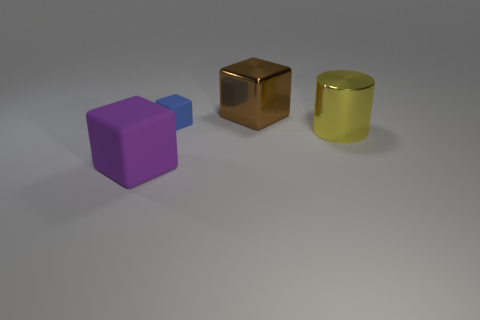How many yellow metallic cylinders have the same size as the yellow shiny thing?
Offer a terse response. 0. What number of things are rubber things that are in front of the large yellow object or tiny brown matte cubes?
Your answer should be compact. 1. Is the number of gray rubber cylinders less than the number of things?
Offer a very short reply. Yes. What shape is the big yellow thing that is made of the same material as the brown thing?
Provide a succinct answer. Cylinder. There is a big metal cylinder; are there any big cubes in front of it?
Offer a very short reply. Yes. Is the number of purple rubber objects that are to the right of the large metal cylinder less than the number of small green rubber things?
Provide a succinct answer. No. What is the big yellow thing made of?
Your answer should be compact. Metal. What color is the metallic cylinder?
Your response must be concise. Yellow. What color is the thing that is both in front of the tiny blue rubber thing and to the left of the metallic block?
Make the answer very short. Purple. Is there any other thing that has the same material as the yellow cylinder?
Provide a succinct answer. Yes. 